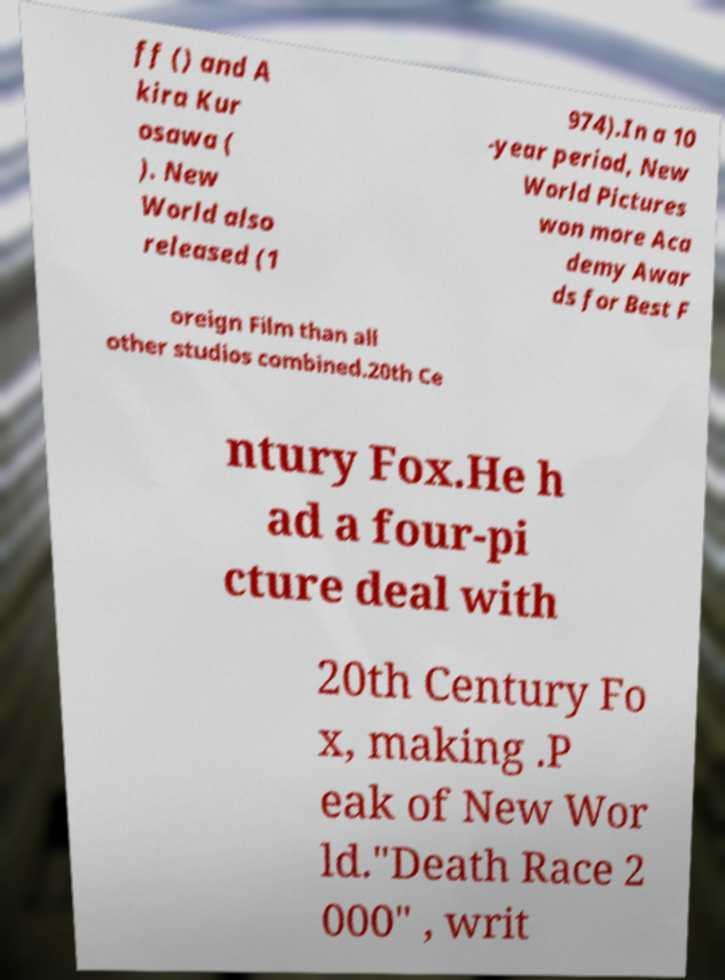Can you accurately transcribe the text from the provided image for me? ff () and A kira Kur osawa ( ). New World also released (1 974).In a 10 -year period, New World Pictures won more Aca demy Awar ds for Best F oreign Film than all other studios combined.20th Ce ntury Fox.He h ad a four-pi cture deal with 20th Century Fo x, making .P eak of New Wor ld."Death Race 2 000" , writ 